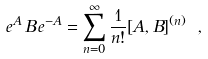<formula> <loc_0><loc_0><loc_500><loc_500>e ^ { A } \, B \, e ^ { - A } = \sum _ { n = 0 } ^ { \infty } \frac { 1 } { n ! } [ A , B ] ^ { ( n ) } \ ,</formula> 